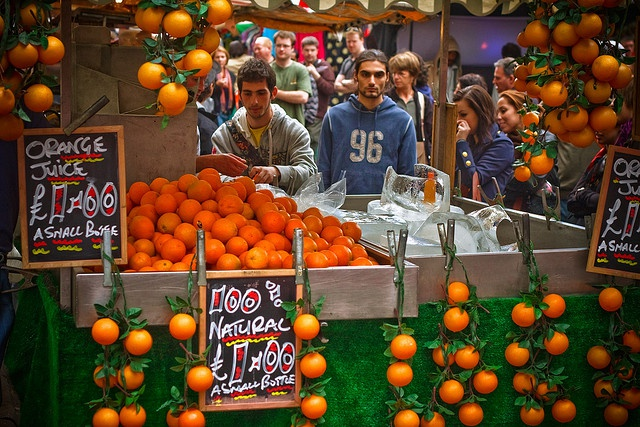Describe the objects in this image and their specific colors. I can see orange in black, maroon, red, and darkgreen tones, orange in black, red, brown, and maroon tones, people in black, navy, darkblue, and gray tones, orange in black, maroon, and brown tones, and people in black, maroon, and gray tones in this image. 